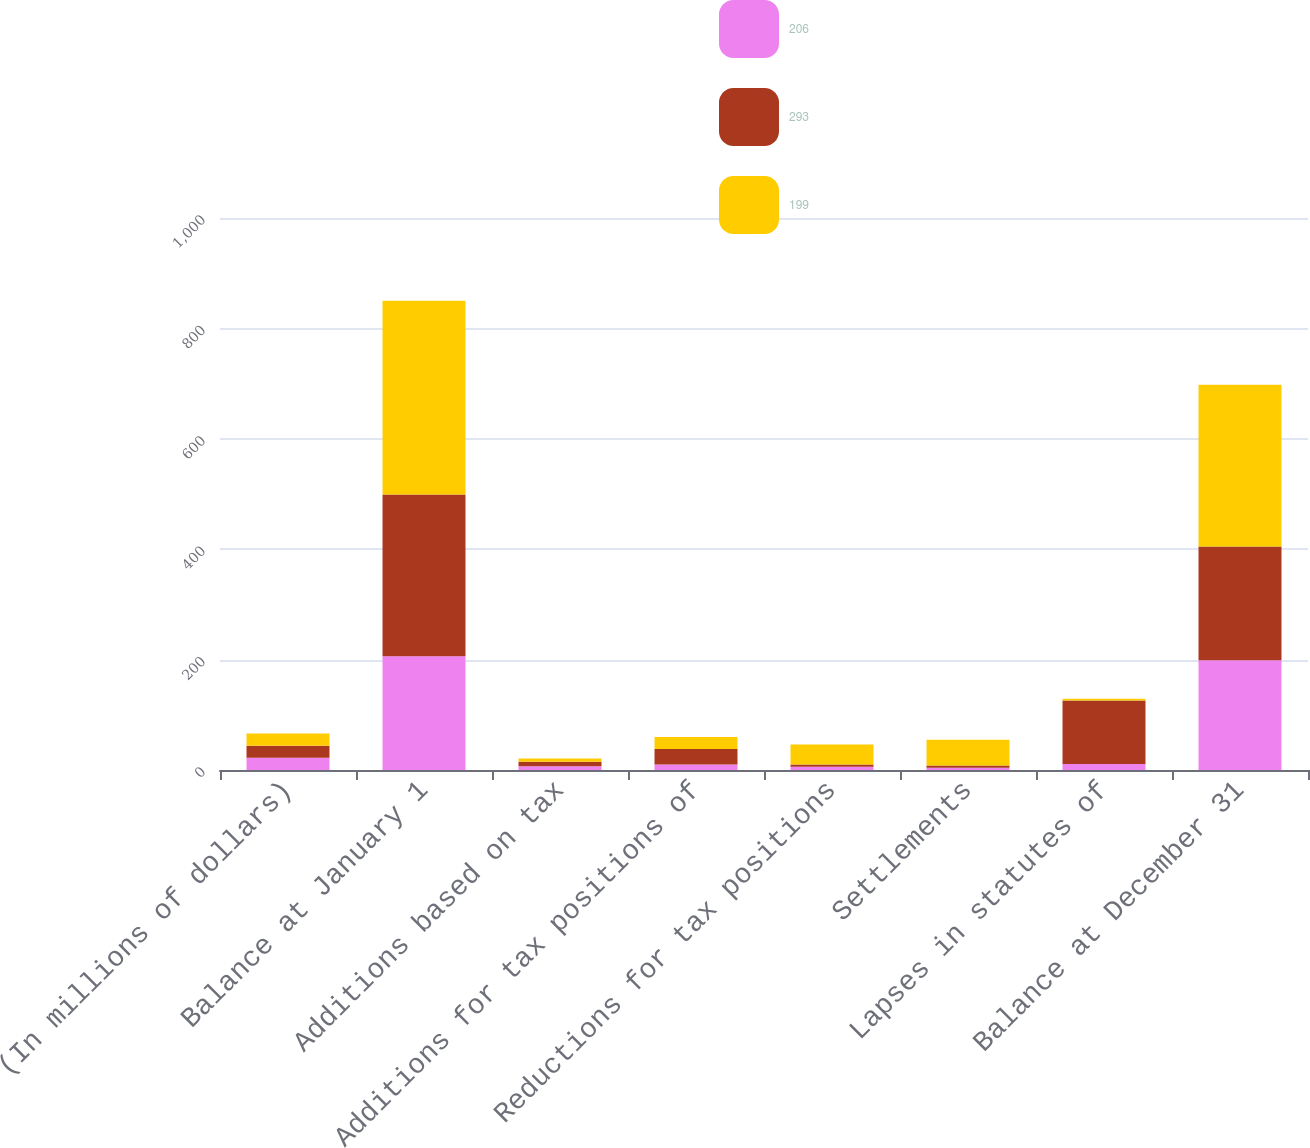<chart> <loc_0><loc_0><loc_500><loc_500><stacked_bar_chart><ecel><fcel>(In millions of dollars)<fcel>Balance at January 1<fcel>Additions based on tax<fcel>Additions for tax positions of<fcel>Reductions for tax positions<fcel>Settlements<fcel>Lapses in statutes of<fcel>Balance at December 31<nl><fcel>206<fcel>22<fcel>206<fcel>7<fcel>10<fcel>6<fcel>4<fcel>11<fcel>199<nl><fcel>293<fcel>22<fcel>293<fcel>8<fcel>28<fcel>4<fcel>4<fcel>115<fcel>206<nl><fcel>199<fcel>22<fcel>351<fcel>6<fcel>22<fcel>36<fcel>47<fcel>3<fcel>293<nl></chart> 